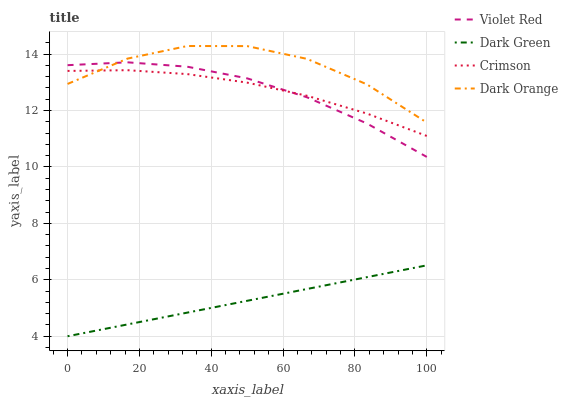Does Violet Red have the minimum area under the curve?
Answer yes or no. No. Does Violet Red have the maximum area under the curve?
Answer yes or no. No. Is Violet Red the smoothest?
Answer yes or no. No. Is Violet Red the roughest?
Answer yes or no. No. Does Violet Red have the lowest value?
Answer yes or no. No. Does Violet Red have the highest value?
Answer yes or no. No. Is Dark Green less than Dark Orange?
Answer yes or no. Yes. Is Violet Red greater than Dark Green?
Answer yes or no. Yes. Does Dark Green intersect Dark Orange?
Answer yes or no. No. 